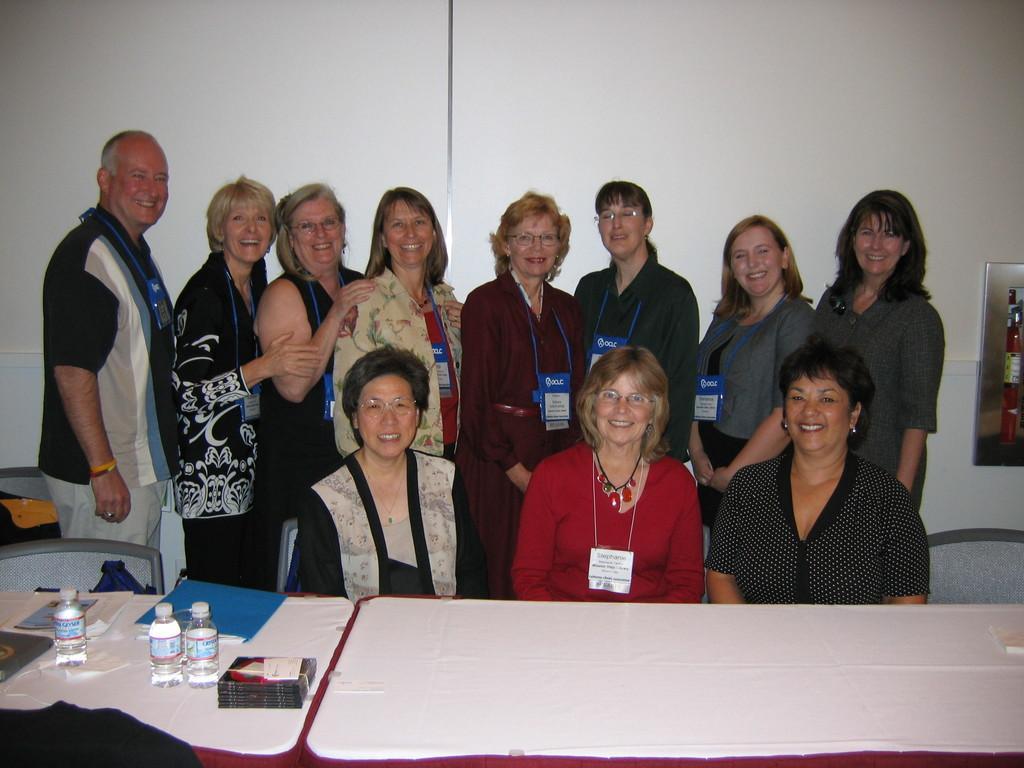How would you summarize this image in a sentence or two? In this image we can see people standing and smiling. At the bottom there are three ladies sitting, before them there are tables and we can see bottles, books and papers placed on the tables. In the background there is a wall. 